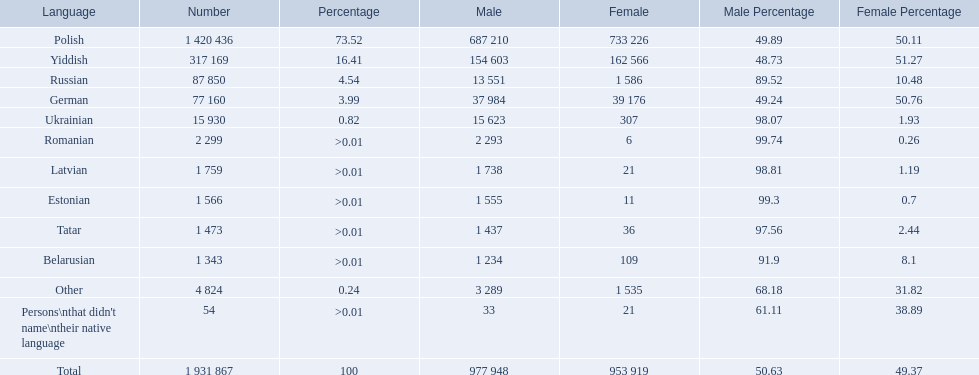Which languages are spoken by more than 50,000 people? Polish, Yiddish, Russian, German. Of these languages, which ones are spoken by less than 15% of the population? Russian, German. Of the remaining two, which one is spoken by 37,984 males? German. What languages are spoken in the warsaw governorate? Polish, Yiddish, Russian, German, Ukrainian, Romanian, Latvian, Estonian, Tatar, Belarusian, Other, Persons\nthat didn't name\ntheir native language. What is the number for russian? 87 850. On this list what is the next lowest number? 77 160. Which language has a number of 77160 speakers? German. 